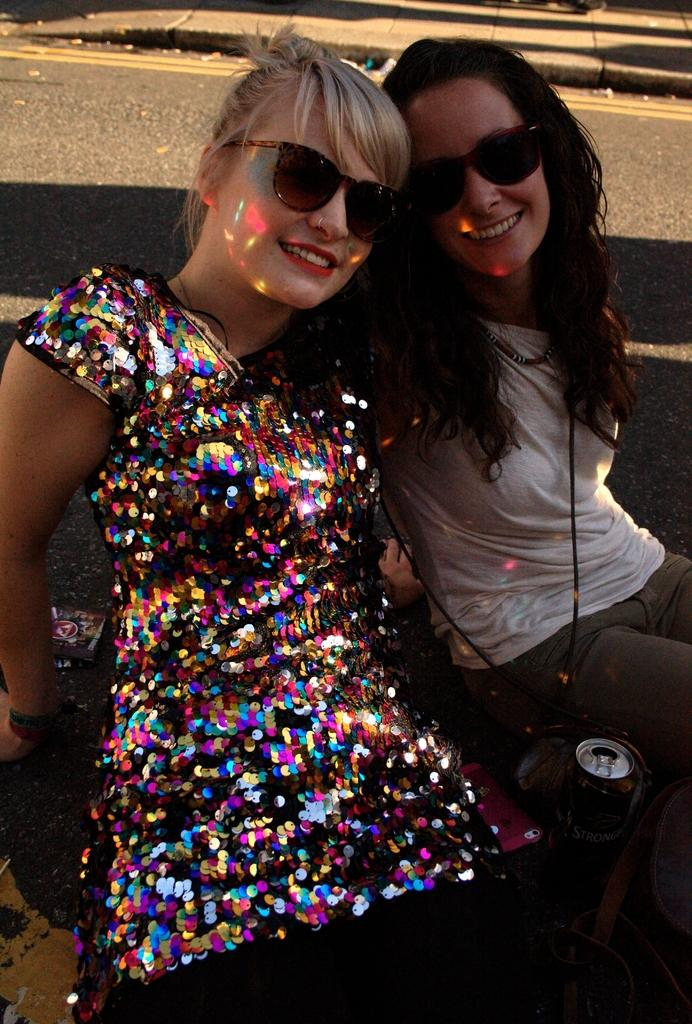How many women are in the image? There are two women in the image. What are the women wearing? The women are wearing glasses. What expression do the women have? The women are smiling. What can be seen in the background of the image? There is a road and a path visible in the background of the image. What electronic device is present in the image? There is a mobile phone in the image. What type of beverage container is in the image? There is a coke tin in the image. What type of toothpaste is the son using in the image? There is no son present in the image, and therefore no toothpaste use can be observed. 